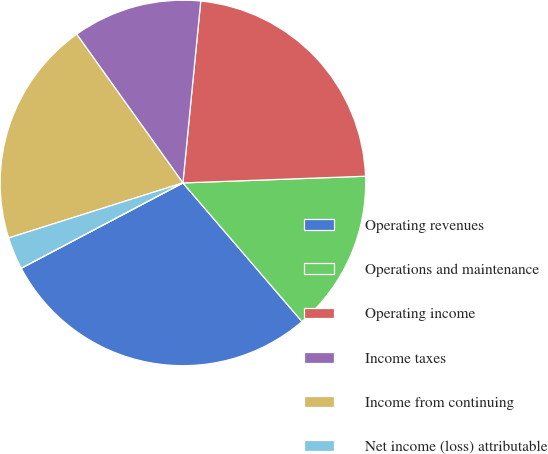<chart> <loc_0><loc_0><loc_500><loc_500><pie_chart><fcel>Operating revenues<fcel>Operations and maintenance<fcel>Operating income<fcel>Income taxes<fcel>Income from continuing<fcel>Net income (loss) attributable<fcel>Income (loss) from continuing<nl><fcel>28.57%<fcel>14.29%<fcel>22.86%<fcel>11.43%<fcel>20.0%<fcel>2.86%<fcel>0.0%<nl></chart> 